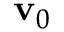<formula> <loc_0><loc_0><loc_500><loc_500>v _ { 0 }</formula> 